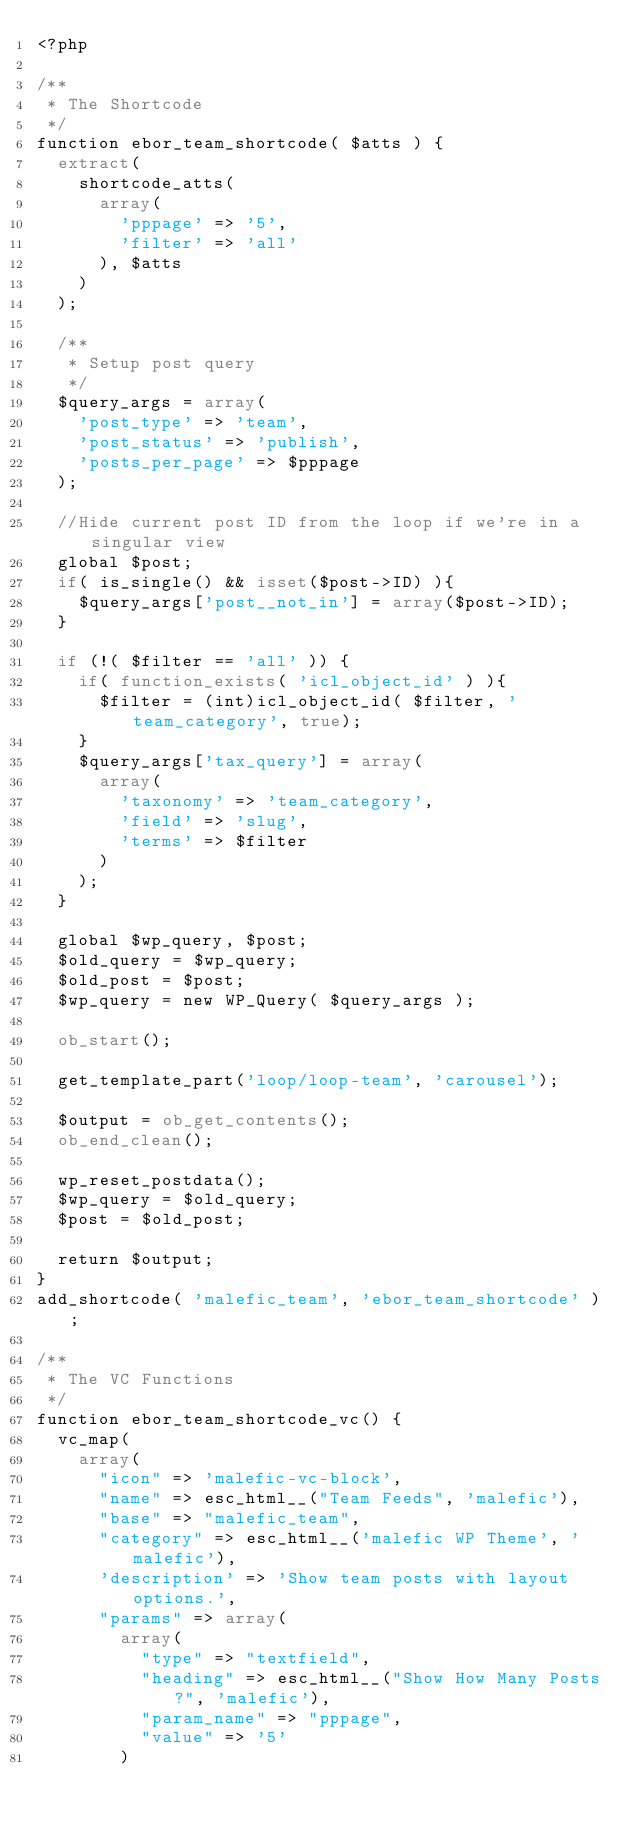Convert code to text. <code><loc_0><loc_0><loc_500><loc_500><_PHP_><?php 

/**
 * The Shortcode
 */
function ebor_team_shortcode( $atts ) {
	extract( 
		shortcode_atts( 
			array(
				'pppage' => '5',
				'filter' => 'all'
			), $atts 
		) 
	);
	
	/**
	 * Setup post query
	 */
	$query_args = array(
		'post_type' => 'team',
		'post_status' => 'publish',
		'posts_per_page' => $pppage
	);
	
	//Hide current post ID from the loop if we're in a singular view
	global $post;
	if( is_single() && isset($post->ID) ){
		$query_args['post__not_in']	= array($post->ID);
	}
	
	if (!( $filter == 'all' )) {
		if( function_exists( 'icl_object_id' ) ){
			$filter = (int)icl_object_id( $filter, 'team_category', true);
		}
		$query_args['tax_query'] = array(
			array(
				'taxonomy' => 'team_category',
				'field' => 'slug',
				'terms' => $filter
			)
		);
	}
	
	global $wp_query, $post;
	$old_query = $wp_query;
	$old_post = $post;
	$wp_query = new WP_Query( $query_args );
	
	ob_start();

	get_template_part('loop/loop-team', 'carousel');
	
	$output = ob_get_contents();
	ob_end_clean();
	
	wp_reset_postdata();
	$wp_query = $old_query;
	$post = $old_post;
	
	return $output;
}
add_shortcode( 'malefic_team', 'ebor_team_shortcode' );

/**
 * The VC Functions
 */
function ebor_team_shortcode_vc() {
	vc_map( 
		array(
			"icon" => 'malefic-vc-block',
			"name" => esc_html__("Team Feeds", 'malefic'),
			"base" => "malefic_team",
			"category" => esc_html__('malefic WP Theme', 'malefic'),
			'description' => 'Show team posts with layout options.',
			"params" => array(
				array(
					"type" => "textfield",
					"heading" => esc_html__("Show How Many Posts?", 'malefic'),
					"param_name" => "pppage",
					"value" => '5'
				)</code> 